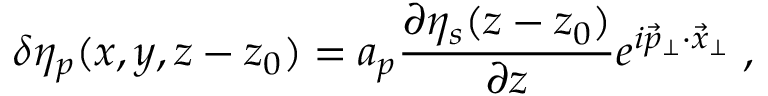Convert formula to latex. <formula><loc_0><loc_0><loc_500><loc_500>\delta \eta _ { p } ( x , y , z - z _ { 0 } ) = a _ { p } \frac { \partial \eta _ { s } ( z - z _ { 0 } ) } { \partial z } e ^ { i \vec { p } _ { \perp } \cdot \vec { x } _ { \perp } } \, ,</formula> 